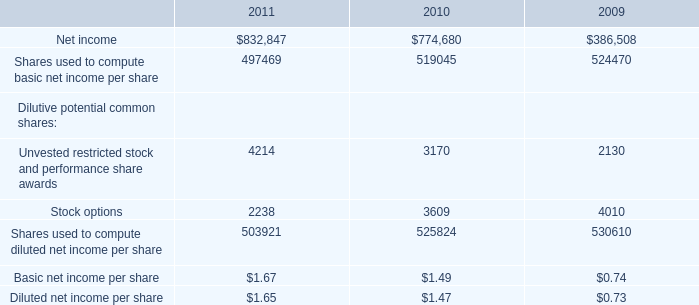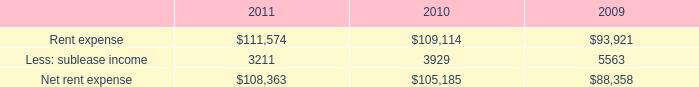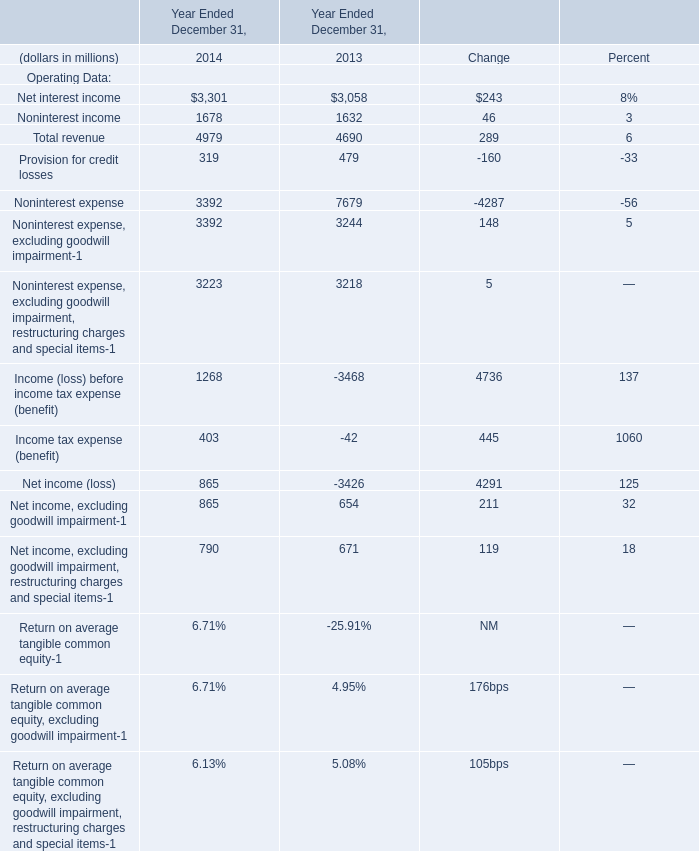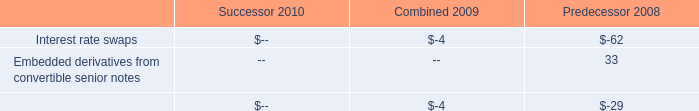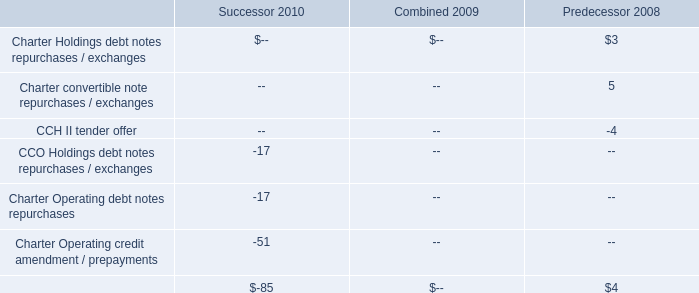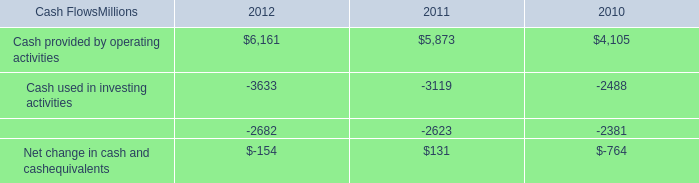What's the sum of Cash used in financing activities of 2011, Net interest income of Year Ended December 31, 2013, and Total revenue of Year Ended December 31, 2013 ? 
Computations: ((2623.0 + 3058.0) + 4690.0)
Answer: 10371.0. 